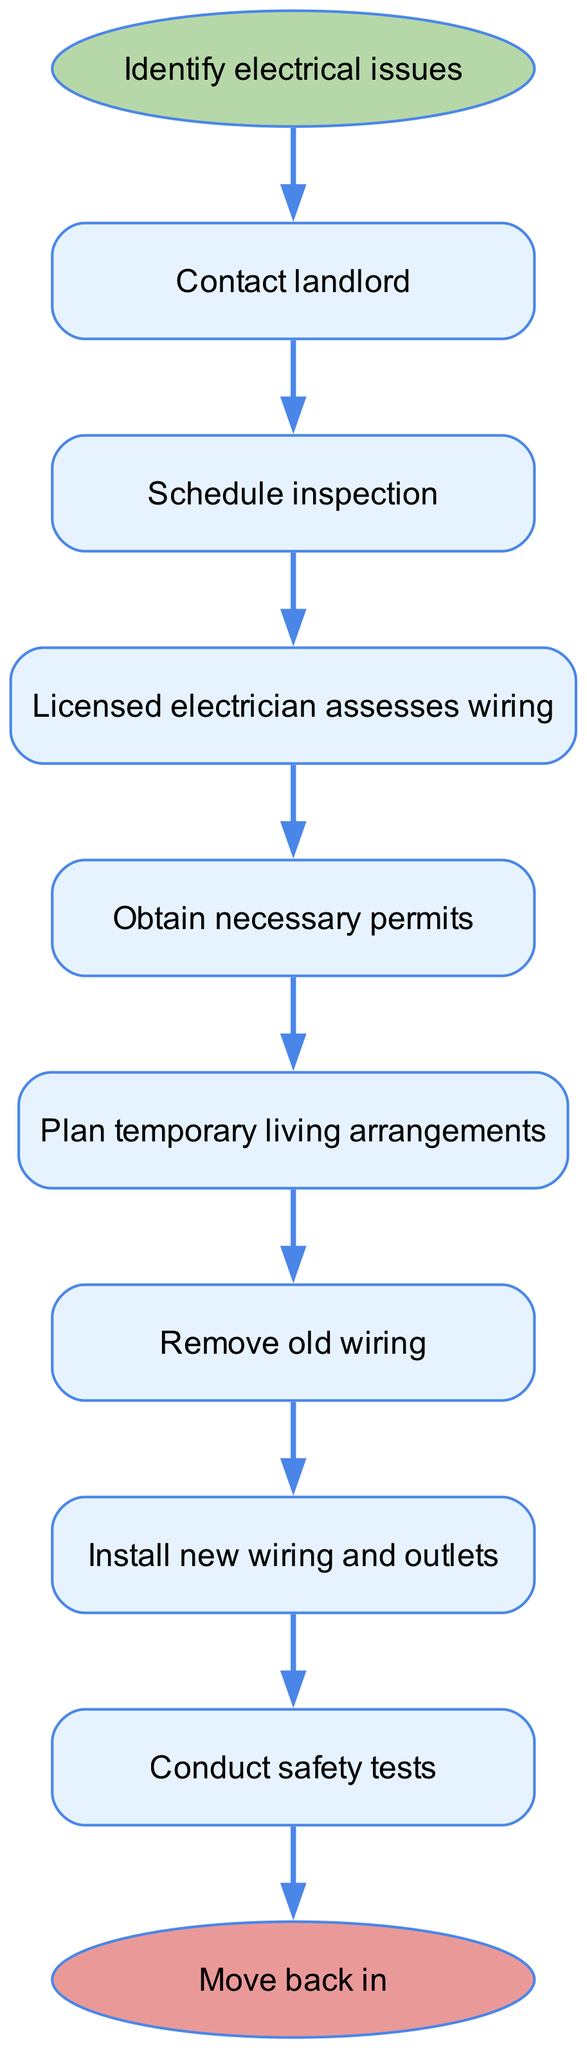What is the starting point of the process? The starting point is identified by the first node in the diagram, which is labeled "Identify electrical issues." This node indicates where the process begins.
Answer: Identify electrical issues What is the last step before moving back in? The last step before the endpoint "Move back in" is found by identifying the final node that connects to the endpoint. This is "Final inspection," which is the step just before moving back in.
Answer: Final inspection How many steps are there in total? The total number of steps can be counted directly from the nodes listed in the steps section. There are eight steps outlined in the process.
Answer: Eight Which step comes after "Remove old wiring"? To find this, we look for the node that directly follows "Remove old wiring" in the sequence outlined in the diagram. The subsequent step is "Install new wiring and outlets."
Answer: Install new wiring and outlets What do you need to plan after obtaining necessary permits? After "Obtain necessary permits," the next action according to the sequence is to "Plan temporary living arrangements." This specifies what comes next in the process.
Answer: Plan temporary living arrangements What is the relationship between "Licensed electrician assesses wiring" and "Obtain necessary permits"? The relationship is sequential, where "Licensed electrician assesses wiring" must be completed before moving to the next step, "Obtain necessary permits." This indicates a dependency.
Answer: Sequential What does the colored shape of the starting point represent? The colored shape that signifies the starting point is an ellipse filled with a specific color (light green), indicating it is the beginning of the flowchart process.
Answer: Starting point What type of inspection takes place after "Conduct safety tests"? Following "Conduct safety tests," the next step is a "Final inspection." This indicates the type of inspection conducted at that stage in the process.
Answer: Final inspection 